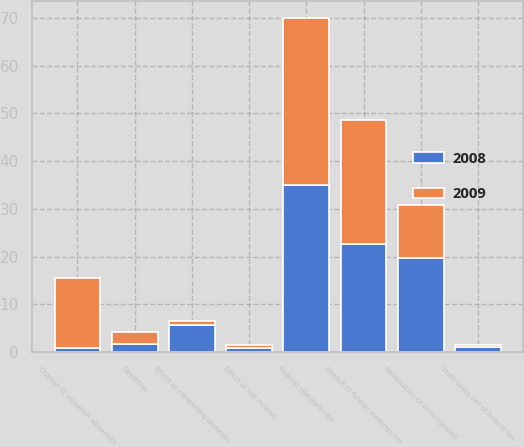Convert chart to OTSL. <chart><loc_0><loc_0><loc_500><loc_500><stacked_bar_chart><ecel><fcel>Federal statutory rate<fcel>State taxes net of federal tax<fcel>Change in valuation allowance<fcel>Impact of foreign earnings net<fcel>Effect of net income<fcel>Effect of completing domestic<fcel>Depletion<fcel>Revaluation of unrecognized<nl><fcel>2008<fcel>35<fcel>1.1<fcel>0.9<fcel>22.6<fcel>0.8<fcel>5.7<fcel>1.7<fcel>19.7<nl><fcel>2009<fcel>35<fcel>0.5<fcel>14.6<fcel>26<fcel>0.8<fcel>0.8<fcel>2.6<fcel>11.2<nl></chart> 